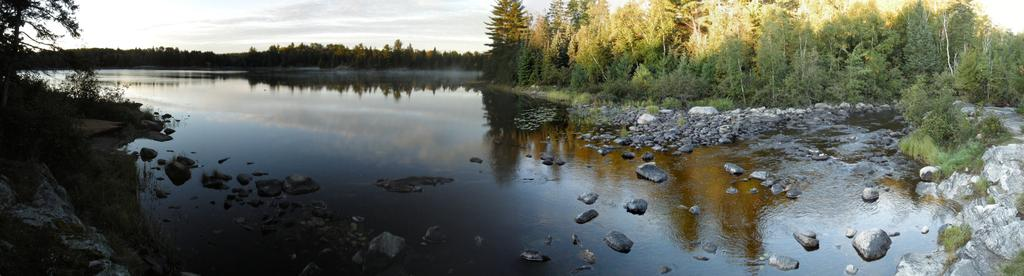What type of natural feature is present in the image? There is a river in the image. What can be seen on the right side of the image? There are stones on the right side of the image. What is visible in the background of the image? There are trees and clouds in the sky in the background of the image. What shape is the art piece in the image? There is no art piece present in the image, so it is not possible to determine its shape. 